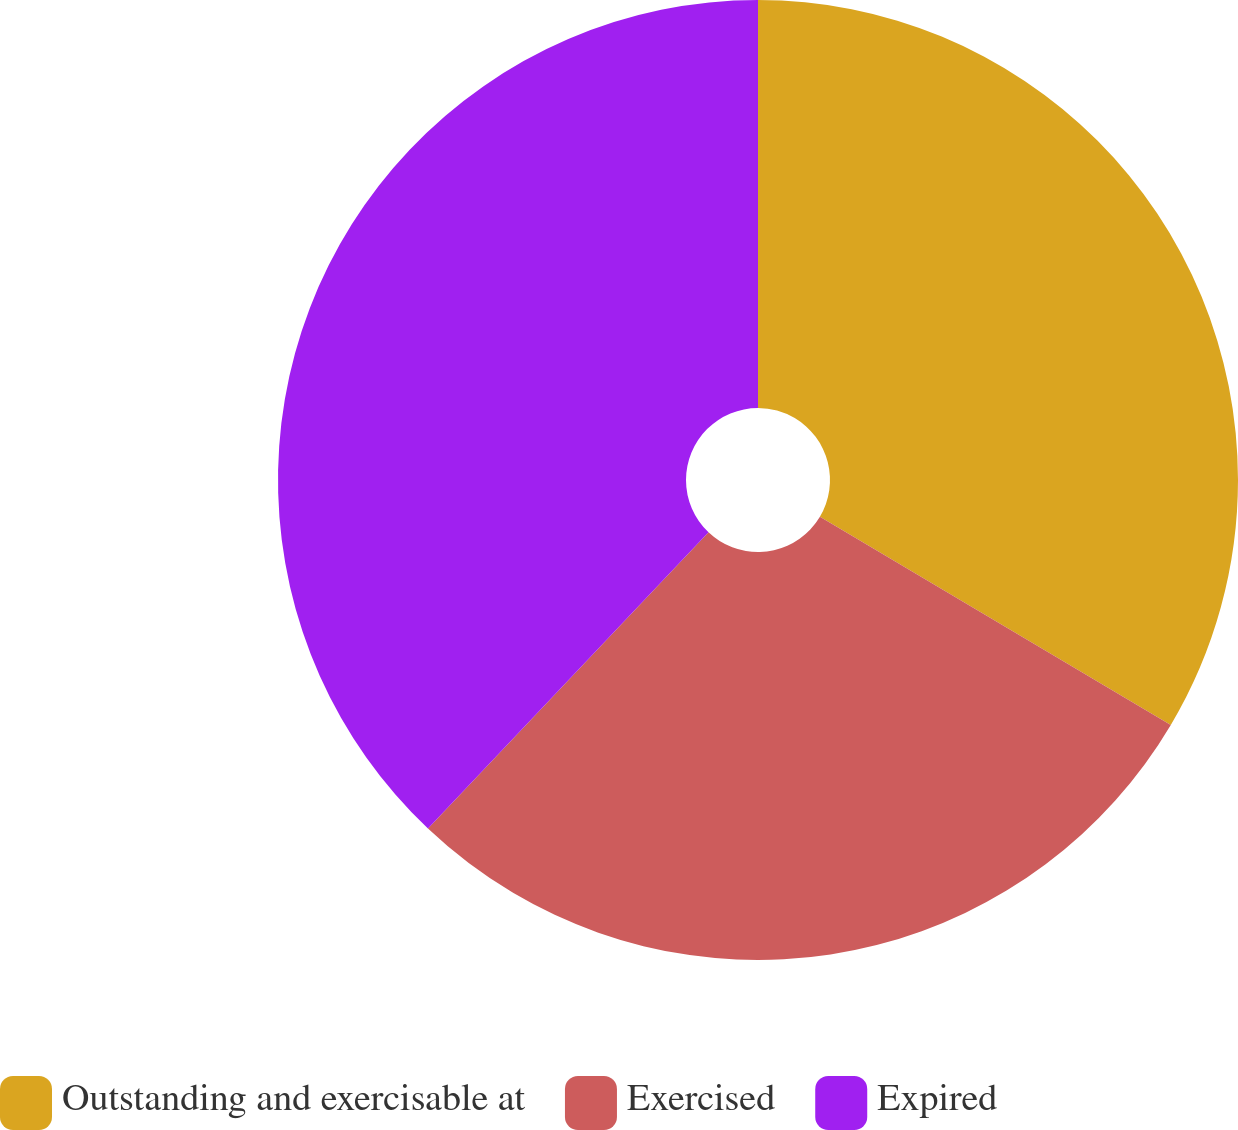<chart> <loc_0><loc_0><loc_500><loc_500><pie_chart><fcel>Outstanding and exercisable at<fcel>Exercised<fcel>Expired<nl><fcel>33.52%<fcel>28.54%<fcel>37.93%<nl></chart> 